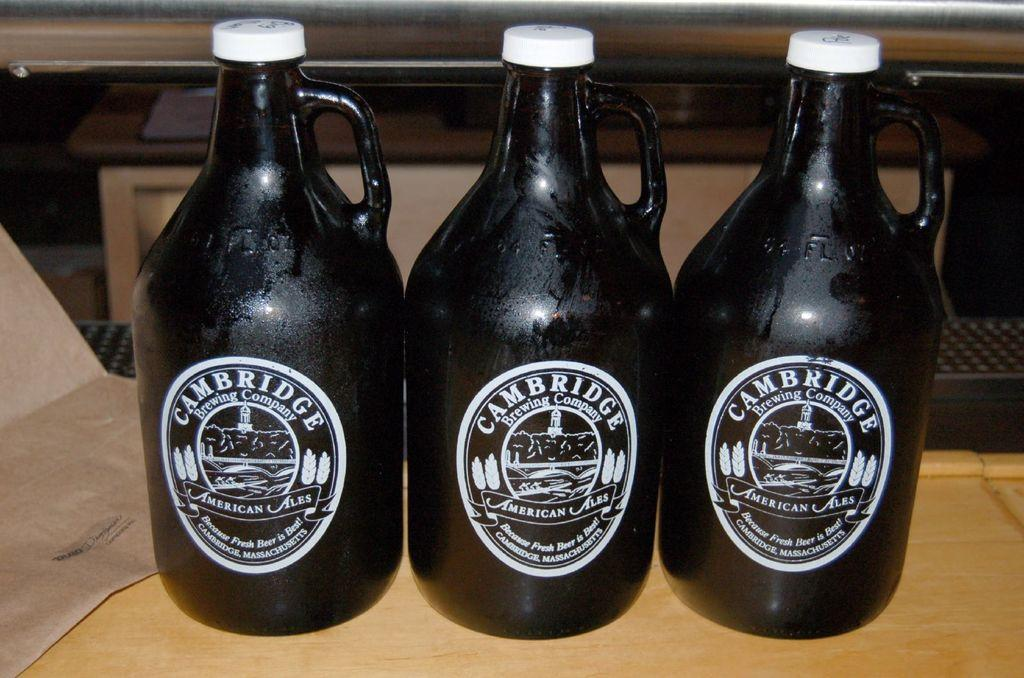<image>
Offer a succinct explanation of the picture presented. three bottles of Cambridge American Ales sit on a wooden counter 